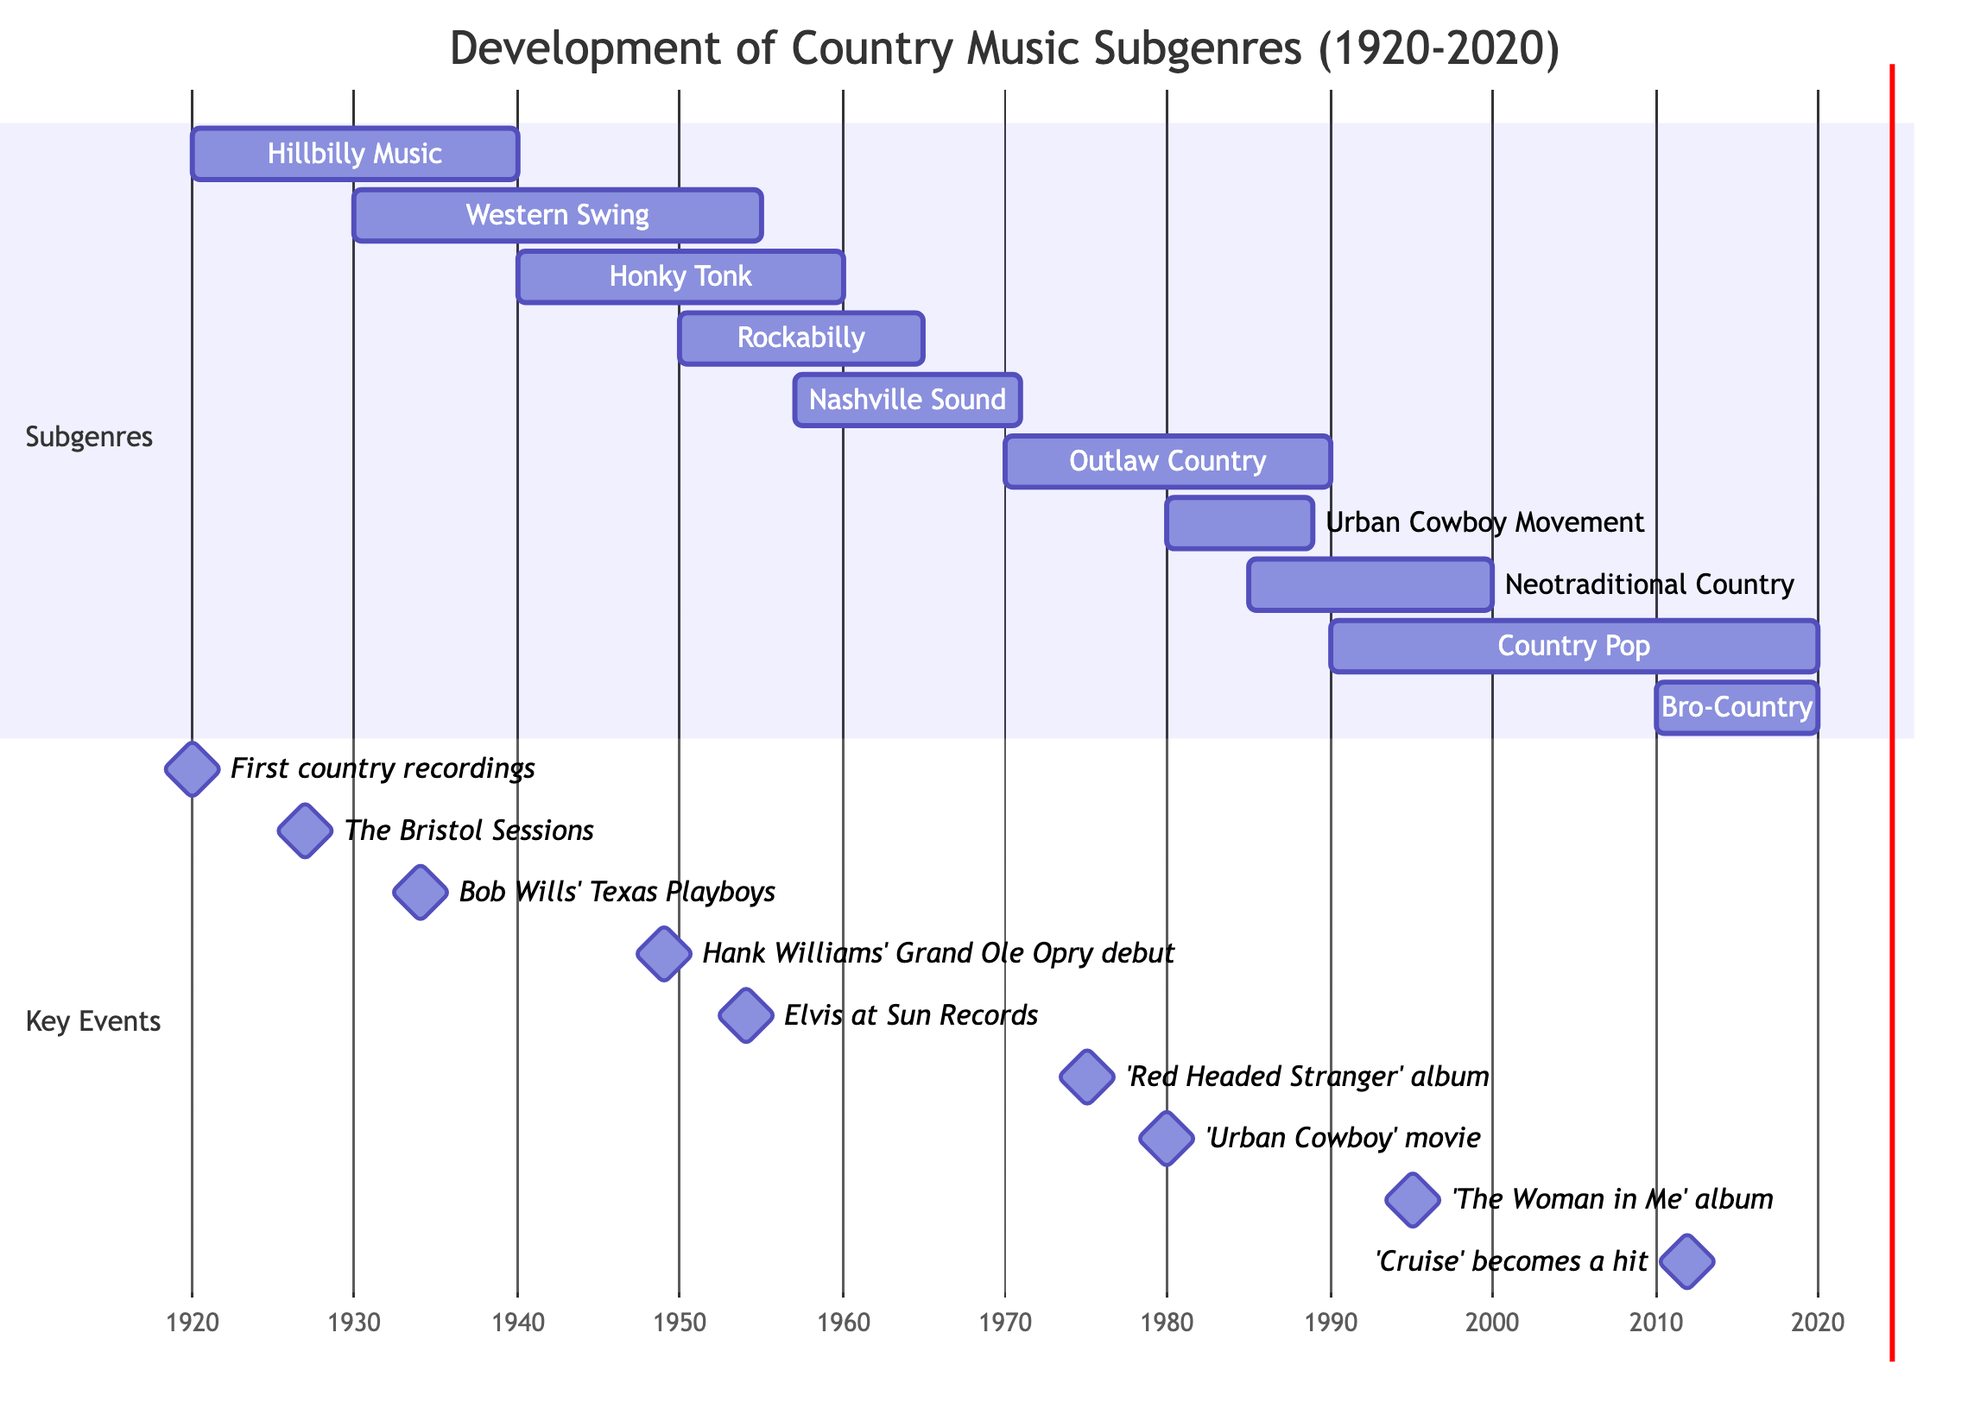What is the earliest subgenre of country music depicted in the diagram? By looking at the Gantt chart, we can see that "Hillbilly Music" starts in 1920, which is the earliest starting point for any listed subgenre.
Answer: Hillbilly Music Which subgenre lasted the longest according to the chart? "Country Pop" spans from 1990 to 2020, lasting for 30 years, which is the most extended duration compared to the other subgenres in the chart.
Answer: Country Pop How many subgenres are represented in the diagram? The Gantt chart lists ten distinct subgenres from 1920 to 2020, indicating that a total of ten subgenres are represented.
Answer: 10 What key milestone is associated with the "Neotraditional Country" subgenre? The chart shows that "Neotraditional Country" includes key milestones such as the return to traditional country themes, specifically mentioning George Strait's rise in popularity.
Answer: Return to traditional country themes Describe the relationship between "Outlaw Country" and "Urban Cowboy Movement." "Outlaw Country" starts in 1970 and ends in 1990, while the "Urban Cowboy Movement" starts in 1980 and ends in 1989, indicating an overlap of nine years where both subgenres were active simultaneously.
Answer: Overlap of 9 years Which artist is primarily associated with "Rockabilly"? The chart specifies that "Elvis Presley" is one of the key artists tied to the "Rockabilly" subgenre, making him a prominent figure for this style in the specified timeline.
Answer: Elvis Presley What notable event occurred in 1975 related to "Outlaw Country"? The Gantt chart notes that the milestone for "Outlaw Country" includes Willie Nelson's 'Red Headed Stranger' album released in 1975, marking a significant event in this subgenre's development.
Answer: 'Red Headed Stranger' album Which two subgenres were both active in the 1980s? By analyzing the years, "Outlaw Country" (1970-1990) and "Urban Cowboy Movement" (1980-1989) were both active in the 1980s, highlighting the concurrent existence of these two movements during that decade.
Answer: Outlaw Country and Urban Cowboy Movement What was the key artist for the Western Swing subgenre? The Gantt chart clearly identifies "Bob Wills" as a key artist associated with the "Western Swing" subgenre, representing his significant contribution to this style.
Answer: Bob Wills 